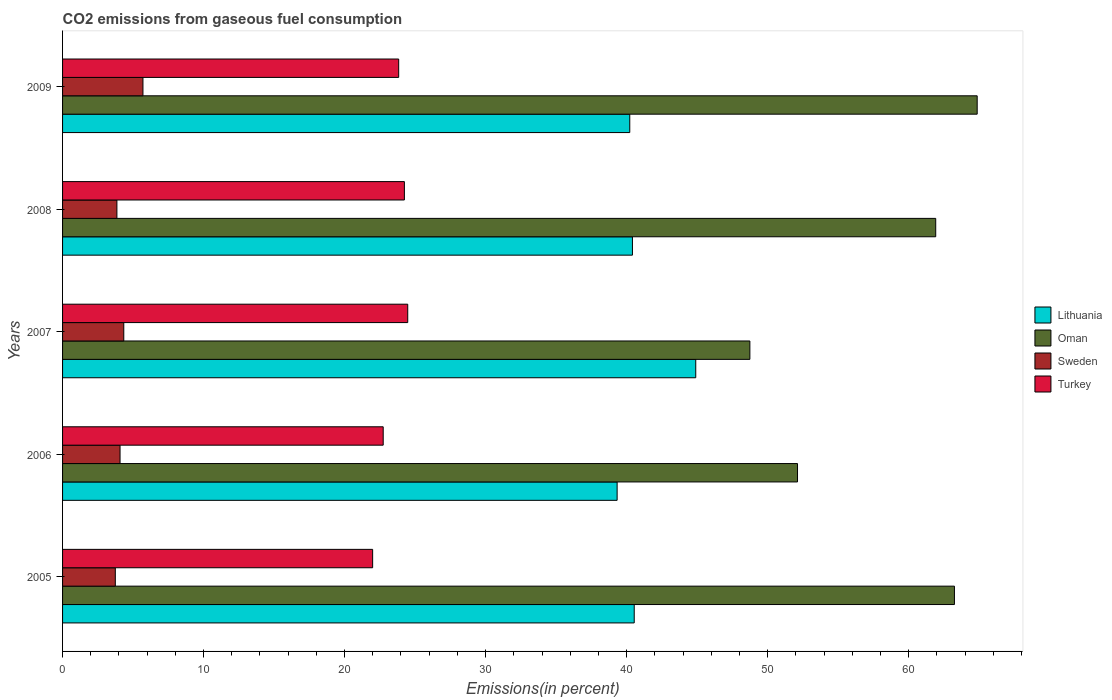How many different coloured bars are there?
Your response must be concise. 4. Are the number of bars per tick equal to the number of legend labels?
Your answer should be compact. Yes. How many bars are there on the 2nd tick from the top?
Give a very brief answer. 4. How many bars are there on the 1st tick from the bottom?
Your answer should be compact. 4. What is the label of the 5th group of bars from the top?
Provide a short and direct response. 2005. What is the total CO2 emitted in Sweden in 2009?
Your answer should be compact. 5.7. Across all years, what is the maximum total CO2 emitted in Turkey?
Your answer should be compact. 24.48. Across all years, what is the minimum total CO2 emitted in Lithuania?
Give a very brief answer. 39.33. In which year was the total CO2 emitted in Oman maximum?
Provide a succinct answer. 2009. What is the total total CO2 emitted in Turkey in the graph?
Your answer should be compact. 117.28. What is the difference between the total CO2 emitted in Oman in 2005 and that in 2008?
Offer a terse response. 1.33. What is the difference between the total CO2 emitted in Lithuania in 2006 and the total CO2 emitted in Turkey in 2008?
Your answer should be very brief. 15.09. What is the average total CO2 emitted in Lithuania per year?
Your answer should be compact. 41.08. In the year 2006, what is the difference between the total CO2 emitted in Lithuania and total CO2 emitted in Oman?
Give a very brief answer. -12.79. In how many years, is the total CO2 emitted in Oman greater than 64 %?
Your answer should be compact. 1. What is the ratio of the total CO2 emitted in Oman in 2008 to that in 2009?
Keep it short and to the point. 0.95. What is the difference between the highest and the second highest total CO2 emitted in Lithuania?
Offer a very short reply. 4.36. What is the difference between the highest and the lowest total CO2 emitted in Sweden?
Ensure brevity in your answer.  1.96. In how many years, is the total CO2 emitted in Turkey greater than the average total CO2 emitted in Turkey taken over all years?
Offer a terse response. 3. Is the sum of the total CO2 emitted in Oman in 2007 and 2009 greater than the maximum total CO2 emitted in Turkey across all years?
Offer a terse response. Yes. What does the 1st bar from the bottom in 2005 represents?
Your answer should be very brief. Lithuania. Are all the bars in the graph horizontal?
Your answer should be compact. Yes. How are the legend labels stacked?
Provide a succinct answer. Vertical. What is the title of the graph?
Ensure brevity in your answer.  CO2 emissions from gaseous fuel consumption. Does "Congo (Republic)" appear as one of the legend labels in the graph?
Your answer should be compact. No. What is the label or title of the X-axis?
Provide a succinct answer. Emissions(in percent). What is the Emissions(in percent) in Lithuania in 2005?
Your answer should be very brief. 40.54. What is the Emissions(in percent) in Oman in 2005?
Ensure brevity in your answer.  63.25. What is the Emissions(in percent) of Sweden in 2005?
Give a very brief answer. 3.74. What is the Emissions(in percent) in Turkey in 2005?
Your answer should be very brief. 21.99. What is the Emissions(in percent) of Lithuania in 2006?
Ensure brevity in your answer.  39.33. What is the Emissions(in percent) of Oman in 2006?
Ensure brevity in your answer.  52.12. What is the Emissions(in percent) of Sweden in 2006?
Your answer should be compact. 4.08. What is the Emissions(in percent) in Turkey in 2006?
Keep it short and to the point. 22.74. What is the Emissions(in percent) of Lithuania in 2007?
Provide a succinct answer. 44.9. What is the Emissions(in percent) of Oman in 2007?
Give a very brief answer. 48.74. What is the Emissions(in percent) of Sweden in 2007?
Your response must be concise. 4.34. What is the Emissions(in percent) in Turkey in 2007?
Your answer should be compact. 24.48. What is the Emissions(in percent) in Lithuania in 2008?
Offer a terse response. 40.41. What is the Emissions(in percent) of Oman in 2008?
Your answer should be very brief. 61.92. What is the Emissions(in percent) in Sweden in 2008?
Provide a succinct answer. 3.85. What is the Emissions(in percent) in Turkey in 2008?
Your response must be concise. 24.24. What is the Emissions(in percent) in Lithuania in 2009?
Make the answer very short. 40.22. What is the Emissions(in percent) of Oman in 2009?
Give a very brief answer. 64.86. What is the Emissions(in percent) of Sweden in 2009?
Offer a terse response. 5.7. What is the Emissions(in percent) of Turkey in 2009?
Your answer should be compact. 23.84. Across all years, what is the maximum Emissions(in percent) in Lithuania?
Offer a very short reply. 44.9. Across all years, what is the maximum Emissions(in percent) in Oman?
Give a very brief answer. 64.86. Across all years, what is the maximum Emissions(in percent) in Sweden?
Offer a very short reply. 5.7. Across all years, what is the maximum Emissions(in percent) of Turkey?
Your response must be concise. 24.48. Across all years, what is the minimum Emissions(in percent) of Lithuania?
Your answer should be very brief. 39.33. Across all years, what is the minimum Emissions(in percent) of Oman?
Your response must be concise. 48.74. Across all years, what is the minimum Emissions(in percent) of Sweden?
Ensure brevity in your answer.  3.74. Across all years, what is the minimum Emissions(in percent) of Turkey?
Your answer should be compact. 21.99. What is the total Emissions(in percent) in Lithuania in the graph?
Give a very brief answer. 205.41. What is the total Emissions(in percent) of Oman in the graph?
Give a very brief answer. 290.89. What is the total Emissions(in percent) in Sweden in the graph?
Offer a terse response. 21.71. What is the total Emissions(in percent) in Turkey in the graph?
Offer a very short reply. 117.28. What is the difference between the Emissions(in percent) in Lithuania in 2005 and that in 2006?
Provide a short and direct response. 1.21. What is the difference between the Emissions(in percent) in Oman in 2005 and that in 2006?
Your response must be concise. 11.13. What is the difference between the Emissions(in percent) of Sweden in 2005 and that in 2006?
Make the answer very short. -0.34. What is the difference between the Emissions(in percent) of Turkey in 2005 and that in 2006?
Provide a short and direct response. -0.75. What is the difference between the Emissions(in percent) of Lithuania in 2005 and that in 2007?
Provide a succinct answer. -4.36. What is the difference between the Emissions(in percent) of Oman in 2005 and that in 2007?
Offer a very short reply. 14.51. What is the difference between the Emissions(in percent) of Sweden in 2005 and that in 2007?
Offer a very short reply. -0.6. What is the difference between the Emissions(in percent) of Turkey in 2005 and that in 2007?
Offer a terse response. -2.49. What is the difference between the Emissions(in percent) of Lithuania in 2005 and that in 2008?
Your answer should be very brief. 0.13. What is the difference between the Emissions(in percent) in Oman in 2005 and that in 2008?
Give a very brief answer. 1.33. What is the difference between the Emissions(in percent) in Sweden in 2005 and that in 2008?
Keep it short and to the point. -0.11. What is the difference between the Emissions(in percent) of Turkey in 2005 and that in 2008?
Your response must be concise. -2.25. What is the difference between the Emissions(in percent) of Lithuania in 2005 and that in 2009?
Provide a succinct answer. 0.32. What is the difference between the Emissions(in percent) of Oman in 2005 and that in 2009?
Your response must be concise. -1.61. What is the difference between the Emissions(in percent) in Sweden in 2005 and that in 2009?
Ensure brevity in your answer.  -1.96. What is the difference between the Emissions(in percent) in Turkey in 2005 and that in 2009?
Provide a succinct answer. -1.85. What is the difference between the Emissions(in percent) of Lithuania in 2006 and that in 2007?
Your response must be concise. -5.58. What is the difference between the Emissions(in percent) in Oman in 2006 and that in 2007?
Provide a short and direct response. 3.38. What is the difference between the Emissions(in percent) in Sweden in 2006 and that in 2007?
Your answer should be very brief. -0.27. What is the difference between the Emissions(in percent) of Turkey in 2006 and that in 2007?
Keep it short and to the point. -1.74. What is the difference between the Emissions(in percent) of Lithuania in 2006 and that in 2008?
Provide a short and direct response. -1.09. What is the difference between the Emissions(in percent) in Oman in 2006 and that in 2008?
Keep it short and to the point. -9.8. What is the difference between the Emissions(in percent) in Sweden in 2006 and that in 2008?
Your answer should be very brief. 0.22. What is the difference between the Emissions(in percent) in Turkey in 2006 and that in 2008?
Give a very brief answer. -1.5. What is the difference between the Emissions(in percent) in Lithuania in 2006 and that in 2009?
Your answer should be very brief. -0.9. What is the difference between the Emissions(in percent) of Oman in 2006 and that in 2009?
Give a very brief answer. -12.74. What is the difference between the Emissions(in percent) in Sweden in 2006 and that in 2009?
Your answer should be compact. -1.62. What is the difference between the Emissions(in percent) of Turkey in 2006 and that in 2009?
Your response must be concise. -1.1. What is the difference between the Emissions(in percent) in Lithuania in 2007 and that in 2008?
Give a very brief answer. 4.49. What is the difference between the Emissions(in percent) in Oman in 2007 and that in 2008?
Your answer should be compact. -13.18. What is the difference between the Emissions(in percent) of Sweden in 2007 and that in 2008?
Offer a terse response. 0.49. What is the difference between the Emissions(in percent) of Turkey in 2007 and that in 2008?
Provide a short and direct response. 0.24. What is the difference between the Emissions(in percent) in Lithuania in 2007 and that in 2009?
Offer a very short reply. 4.68. What is the difference between the Emissions(in percent) of Oman in 2007 and that in 2009?
Keep it short and to the point. -16.12. What is the difference between the Emissions(in percent) in Sweden in 2007 and that in 2009?
Offer a terse response. -1.36. What is the difference between the Emissions(in percent) of Turkey in 2007 and that in 2009?
Offer a terse response. 0.64. What is the difference between the Emissions(in percent) in Lithuania in 2008 and that in 2009?
Keep it short and to the point. 0.19. What is the difference between the Emissions(in percent) in Oman in 2008 and that in 2009?
Provide a short and direct response. -2.94. What is the difference between the Emissions(in percent) in Sweden in 2008 and that in 2009?
Offer a very short reply. -1.85. What is the difference between the Emissions(in percent) in Turkey in 2008 and that in 2009?
Provide a succinct answer. 0.4. What is the difference between the Emissions(in percent) in Lithuania in 2005 and the Emissions(in percent) in Oman in 2006?
Keep it short and to the point. -11.58. What is the difference between the Emissions(in percent) of Lithuania in 2005 and the Emissions(in percent) of Sweden in 2006?
Your response must be concise. 36.46. What is the difference between the Emissions(in percent) of Lithuania in 2005 and the Emissions(in percent) of Turkey in 2006?
Make the answer very short. 17.8. What is the difference between the Emissions(in percent) in Oman in 2005 and the Emissions(in percent) in Sweden in 2006?
Provide a succinct answer. 59.17. What is the difference between the Emissions(in percent) in Oman in 2005 and the Emissions(in percent) in Turkey in 2006?
Keep it short and to the point. 40.51. What is the difference between the Emissions(in percent) in Sweden in 2005 and the Emissions(in percent) in Turkey in 2006?
Your response must be concise. -19. What is the difference between the Emissions(in percent) of Lithuania in 2005 and the Emissions(in percent) of Oman in 2007?
Offer a very short reply. -8.2. What is the difference between the Emissions(in percent) in Lithuania in 2005 and the Emissions(in percent) in Sweden in 2007?
Your answer should be compact. 36.2. What is the difference between the Emissions(in percent) of Lithuania in 2005 and the Emissions(in percent) of Turkey in 2007?
Ensure brevity in your answer.  16.06. What is the difference between the Emissions(in percent) of Oman in 2005 and the Emissions(in percent) of Sweden in 2007?
Give a very brief answer. 58.91. What is the difference between the Emissions(in percent) in Oman in 2005 and the Emissions(in percent) in Turkey in 2007?
Give a very brief answer. 38.77. What is the difference between the Emissions(in percent) of Sweden in 2005 and the Emissions(in percent) of Turkey in 2007?
Provide a succinct answer. -20.74. What is the difference between the Emissions(in percent) in Lithuania in 2005 and the Emissions(in percent) in Oman in 2008?
Give a very brief answer. -21.38. What is the difference between the Emissions(in percent) of Lithuania in 2005 and the Emissions(in percent) of Sweden in 2008?
Offer a terse response. 36.69. What is the difference between the Emissions(in percent) in Lithuania in 2005 and the Emissions(in percent) in Turkey in 2008?
Provide a short and direct response. 16.3. What is the difference between the Emissions(in percent) in Oman in 2005 and the Emissions(in percent) in Sweden in 2008?
Offer a very short reply. 59.39. What is the difference between the Emissions(in percent) of Oman in 2005 and the Emissions(in percent) of Turkey in 2008?
Make the answer very short. 39.01. What is the difference between the Emissions(in percent) in Sweden in 2005 and the Emissions(in percent) in Turkey in 2008?
Offer a terse response. -20.5. What is the difference between the Emissions(in percent) in Lithuania in 2005 and the Emissions(in percent) in Oman in 2009?
Ensure brevity in your answer.  -24.32. What is the difference between the Emissions(in percent) in Lithuania in 2005 and the Emissions(in percent) in Sweden in 2009?
Your answer should be very brief. 34.84. What is the difference between the Emissions(in percent) in Lithuania in 2005 and the Emissions(in percent) in Turkey in 2009?
Keep it short and to the point. 16.7. What is the difference between the Emissions(in percent) of Oman in 2005 and the Emissions(in percent) of Sweden in 2009?
Offer a very short reply. 57.55. What is the difference between the Emissions(in percent) of Oman in 2005 and the Emissions(in percent) of Turkey in 2009?
Provide a succinct answer. 39.41. What is the difference between the Emissions(in percent) in Sweden in 2005 and the Emissions(in percent) in Turkey in 2009?
Keep it short and to the point. -20.1. What is the difference between the Emissions(in percent) in Lithuania in 2006 and the Emissions(in percent) in Oman in 2007?
Your response must be concise. -9.41. What is the difference between the Emissions(in percent) in Lithuania in 2006 and the Emissions(in percent) in Sweden in 2007?
Your response must be concise. 34.99. What is the difference between the Emissions(in percent) of Lithuania in 2006 and the Emissions(in percent) of Turkey in 2007?
Your answer should be compact. 14.85. What is the difference between the Emissions(in percent) of Oman in 2006 and the Emissions(in percent) of Sweden in 2007?
Offer a terse response. 47.78. What is the difference between the Emissions(in percent) in Oman in 2006 and the Emissions(in percent) in Turkey in 2007?
Your answer should be compact. 27.64. What is the difference between the Emissions(in percent) in Sweden in 2006 and the Emissions(in percent) in Turkey in 2007?
Your answer should be very brief. -20.4. What is the difference between the Emissions(in percent) in Lithuania in 2006 and the Emissions(in percent) in Oman in 2008?
Your response must be concise. -22.59. What is the difference between the Emissions(in percent) in Lithuania in 2006 and the Emissions(in percent) in Sweden in 2008?
Offer a very short reply. 35.47. What is the difference between the Emissions(in percent) of Lithuania in 2006 and the Emissions(in percent) of Turkey in 2008?
Your answer should be very brief. 15.09. What is the difference between the Emissions(in percent) of Oman in 2006 and the Emissions(in percent) of Sweden in 2008?
Give a very brief answer. 48.27. What is the difference between the Emissions(in percent) in Oman in 2006 and the Emissions(in percent) in Turkey in 2008?
Make the answer very short. 27.88. What is the difference between the Emissions(in percent) of Sweden in 2006 and the Emissions(in percent) of Turkey in 2008?
Your response must be concise. -20.16. What is the difference between the Emissions(in percent) of Lithuania in 2006 and the Emissions(in percent) of Oman in 2009?
Ensure brevity in your answer.  -25.53. What is the difference between the Emissions(in percent) of Lithuania in 2006 and the Emissions(in percent) of Sweden in 2009?
Provide a succinct answer. 33.63. What is the difference between the Emissions(in percent) in Lithuania in 2006 and the Emissions(in percent) in Turkey in 2009?
Offer a very short reply. 15.49. What is the difference between the Emissions(in percent) of Oman in 2006 and the Emissions(in percent) of Sweden in 2009?
Keep it short and to the point. 46.42. What is the difference between the Emissions(in percent) of Oman in 2006 and the Emissions(in percent) of Turkey in 2009?
Ensure brevity in your answer.  28.28. What is the difference between the Emissions(in percent) in Sweden in 2006 and the Emissions(in percent) in Turkey in 2009?
Your answer should be very brief. -19.76. What is the difference between the Emissions(in percent) in Lithuania in 2007 and the Emissions(in percent) in Oman in 2008?
Keep it short and to the point. -17.02. What is the difference between the Emissions(in percent) in Lithuania in 2007 and the Emissions(in percent) in Sweden in 2008?
Your answer should be very brief. 41.05. What is the difference between the Emissions(in percent) of Lithuania in 2007 and the Emissions(in percent) of Turkey in 2008?
Provide a succinct answer. 20.66. What is the difference between the Emissions(in percent) of Oman in 2007 and the Emissions(in percent) of Sweden in 2008?
Ensure brevity in your answer.  44.89. What is the difference between the Emissions(in percent) in Oman in 2007 and the Emissions(in percent) in Turkey in 2008?
Offer a terse response. 24.5. What is the difference between the Emissions(in percent) of Sweden in 2007 and the Emissions(in percent) of Turkey in 2008?
Your response must be concise. -19.9. What is the difference between the Emissions(in percent) in Lithuania in 2007 and the Emissions(in percent) in Oman in 2009?
Your response must be concise. -19.96. What is the difference between the Emissions(in percent) in Lithuania in 2007 and the Emissions(in percent) in Sweden in 2009?
Make the answer very short. 39.2. What is the difference between the Emissions(in percent) of Lithuania in 2007 and the Emissions(in percent) of Turkey in 2009?
Make the answer very short. 21.07. What is the difference between the Emissions(in percent) in Oman in 2007 and the Emissions(in percent) in Sweden in 2009?
Offer a terse response. 43.04. What is the difference between the Emissions(in percent) in Oman in 2007 and the Emissions(in percent) in Turkey in 2009?
Provide a succinct answer. 24.9. What is the difference between the Emissions(in percent) of Sweden in 2007 and the Emissions(in percent) of Turkey in 2009?
Provide a succinct answer. -19.5. What is the difference between the Emissions(in percent) in Lithuania in 2008 and the Emissions(in percent) in Oman in 2009?
Keep it short and to the point. -24.45. What is the difference between the Emissions(in percent) in Lithuania in 2008 and the Emissions(in percent) in Sweden in 2009?
Give a very brief answer. 34.71. What is the difference between the Emissions(in percent) in Lithuania in 2008 and the Emissions(in percent) in Turkey in 2009?
Offer a terse response. 16.58. What is the difference between the Emissions(in percent) in Oman in 2008 and the Emissions(in percent) in Sweden in 2009?
Keep it short and to the point. 56.22. What is the difference between the Emissions(in percent) in Oman in 2008 and the Emissions(in percent) in Turkey in 2009?
Provide a short and direct response. 38.08. What is the difference between the Emissions(in percent) in Sweden in 2008 and the Emissions(in percent) in Turkey in 2009?
Offer a very short reply. -19.98. What is the average Emissions(in percent) in Lithuania per year?
Provide a succinct answer. 41.08. What is the average Emissions(in percent) in Oman per year?
Provide a short and direct response. 58.18. What is the average Emissions(in percent) in Sweden per year?
Make the answer very short. 4.34. What is the average Emissions(in percent) of Turkey per year?
Keep it short and to the point. 23.46. In the year 2005, what is the difference between the Emissions(in percent) of Lithuania and Emissions(in percent) of Oman?
Your answer should be very brief. -22.71. In the year 2005, what is the difference between the Emissions(in percent) of Lithuania and Emissions(in percent) of Sweden?
Your response must be concise. 36.8. In the year 2005, what is the difference between the Emissions(in percent) in Lithuania and Emissions(in percent) in Turkey?
Provide a short and direct response. 18.55. In the year 2005, what is the difference between the Emissions(in percent) of Oman and Emissions(in percent) of Sweden?
Your response must be concise. 59.51. In the year 2005, what is the difference between the Emissions(in percent) of Oman and Emissions(in percent) of Turkey?
Offer a very short reply. 41.26. In the year 2005, what is the difference between the Emissions(in percent) in Sweden and Emissions(in percent) in Turkey?
Ensure brevity in your answer.  -18.25. In the year 2006, what is the difference between the Emissions(in percent) of Lithuania and Emissions(in percent) of Oman?
Offer a very short reply. -12.79. In the year 2006, what is the difference between the Emissions(in percent) in Lithuania and Emissions(in percent) in Sweden?
Your response must be concise. 35.25. In the year 2006, what is the difference between the Emissions(in percent) of Lithuania and Emissions(in percent) of Turkey?
Your response must be concise. 16.59. In the year 2006, what is the difference between the Emissions(in percent) in Oman and Emissions(in percent) in Sweden?
Provide a short and direct response. 48.04. In the year 2006, what is the difference between the Emissions(in percent) in Oman and Emissions(in percent) in Turkey?
Your answer should be compact. 29.38. In the year 2006, what is the difference between the Emissions(in percent) of Sweden and Emissions(in percent) of Turkey?
Your answer should be very brief. -18.66. In the year 2007, what is the difference between the Emissions(in percent) of Lithuania and Emissions(in percent) of Oman?
Offer a terse response. -3.84. In the year 2007, what is the difference between the Emissions(in percent) of Lithuania and Emissions(in percent) of Sweden?
Your response must be concise. 40.56. In the year 2007, what is the difference between the Emissions(in percent) of Lithuania and Emissions(in percent) of Turkey?
Make the answer very short. 20.42. In the year 2007, what is the difference between the Emissions(in percent) of Oman and Emissions(in percent) of Sweden?
Keep it short and to the point. 44.4. In the year 2007, what is the difference between the Emissions(in percent) of Oman and Emissions(in percent) of Turkey?
Ensure brevity in your answer.  24.26. In the year 2007, what is the difference between the Emissions(in percent) in Sweden and Emissions(in percent) in Turkey?
Ensure brevity in your answer.  -20.14. In the year 2008, what is the difference between the Emissions(in percent) of Lithuania and Emissions(in percent) of Oman?
Your response must be concise. -21.51. In the year 2008, what is the difference between the Emissions(in percent) in Lithuania and Emissions(in percent) in Sweden?
Your response must be concise. 36.56. In the year 2008, what is the difference between the Emissions(in percent) of Lithuania and Emissions(in percent) of Turkey?
Give a very brief answer. 16.17. In the year 2008, what is the difference between the Emissions(in percent) in Oman and Emissions(in percent) in Sweden?
Provide a succinct answer. 58.07. In the year 2008, what is the difference between the Emissions(in percent) of Oman and Emissions(in percent) of Turkey?
Offer a very short reply. 37.68. In the year 2008, what is the difference between the Emissions(in percent) of Sweden and Emissions(in percent) of Turkey?
Ensure brevity in your answer.  -20.39. In the year 2009, what is the difference between the Emissions(in percent) of Lithuania and Emissions(in percent) of Oman?
Your answer should be compact. -24.64. In the year 2009, what is the difference between the Emissions(in percent) in Lithuania and Emissions(in percent) in Sweden?
Provide a succinct answer. 34.52. In the year 2009, what is the difference between the Emissions(in percent) of Lithuania and Emissions(in percent) of Turkey?
Give a very brief answer. 16.39. In the year 2009, what is the difference between the Emissions(in percent) in Oman and Emissions(in percent) in Sweden?
Your answer should be very brief. 59.16. In the year 2009, what is the difference between the Emissions(in percent) of Oman and Emissions(in percent) of Turkey?
Your answer should be compact. 41.02. In the year 2009, what is the difference between the Emissions(in percent) of Sweden and Emissions(in percent) of Turkey?
Give a very brief answer. -18.14. What is the ratio of the Emissions(in percent) of Lithuania in 2005 to that in 2006?
Provide a short and direct response. 1.03. What is the ratio of the Emissions(in percent) of Oman in 2005 to that in 2006?
Keep it short and to the point. 1.21. What is the ratio of the Emissions(in percent) of Sweden in 2005 to that in 2006?
Ensure brevity in your answer.  0.92. What is the ratio of the Emissions(in percent) in Turkey in 2005 to that in 2006?
Provide a short and direct response. 0.97. What is the ratio of the Emissions(in percent) in Lithuania in 2005 to that in 2007?
Provide a short and direct response. 0.9. What is the ratio of the Emissions(in percent) in Oman in 2005 to that in 2007?
Provide a succinct answer. 1.3. What is the ratio of the Emissions(in percent) in Sweden in 2005 to that in 2007?
Keep it short and to the point. 0.86. What is the ratio of the Emissions(in percent) in Turkey in 2005 to that in 2007?
Offer a very short reply. 0.9. What is the ratio of the Emissions(in percent) of Oman in 2005 to that in 2008?
Your answer should be compact. 1.02. What is the ratio of the Emissions(in percent) in Sweden in 2005 to that in 2008?
Provide a succinct answer. 0.97. What is the ratio of the Emissions(in percent) in Turkey in 2005 to that in 2008?
Make the answer very short. 0.91. What is the ratio of the Emissions(in percent) in Oman in 2005 to that in 2009?
Ensure brevity in your answer.  0.98. What is the ratio of the Emissions(in percent) in Sweden in 2005 to that in 2009?
Keep it short and to the point. 0.66. What is the ratio of the Emissions(in percent) in Turkey in 2005 to that in 2009?
Offer a very short reply. 0.92. What is the ratio of the Emissions(in percent) of Lithuania in 2006 to that in 2007?
Keep it short and to the point. 0.88. What is the ratio of the Emissions(in percent) of Oman in 2006 to that in 2007?
Give a very brief answer. 1.07. What is the ratio of the Emissions(in percent) in Sweden in 2006 to that in 2007?
Offer a very short reply. 0.94. What is the ratio of the Emissions(in percent) in Turkey in 2006 to that in 2007?
Offer a very short reply. 0.93. What is the ratio of the Emissions(in percent) of Lithuania in 2006 to that in 2008?
Provide a short and direct response. 0.97. What is the ratio of the Emissions(in percent) in Oman in 2006 to that in 2008?
Provide a succinct answer. 0.84. What is the ratio of the Emissions(in percent) of Sweden in 2006 to that in 2008?
Your response must be concise. 1.06. What is the ratio of the Emissions(in percent) in Turkey in 2006 to that in 2008?
Give a very brief answer. 0.94. What is the ratio of the Emissions(in percent) in Lithuania in 2006 to that in 2009?
Provide a succinct answer. 0.98. What is the ratio of the Emissions(in percent) of Oman in 2006 to that in 2009?
Your answer should be very brief. 0.8. What is the ratio of the Emissions(in percent) of Sweden in 2006 to that in 2009?
Your response must be concise. 0.71. What is the ratio of the Emissions(in percent) of Turkey in 2006 to that in 2009?
Keep it short and to the point. 0.95. What is the ratio of the Emissions(in percent) of Oman in 2007 to that in 2008?
Keep it short and to the point. 0.79. What is the ratio of the Emissions(in percent) in Sweden in 2007 to that in 2008?
Your answer should be very brief. 1.13. What is the ratio of the Emissions(in percent) of Turkey in 2007 to that in 2008?
Offer a very short reply. 1.01. What is the ratio of the Emissions(in percent) of Lithuania in 2007 to that in 2009?
Your answer should be compact. 1.12. What is the ratio of the Emissions(in percent) of Oman in 2007 to that in 2009?
Keep it short and to the point. 0.75. What is the ratio of the Emissions(in percent) of Sweden in 2007 to that in 2009?
Ensure brevity in your answer.  0.76. What is the ratio of the Emissions(in percent) of Turkey in 2007 to that in 2009?
Provide a succinct answer. 1.03. What is the ratio of the Emissions(in percent) in Oman in 2008 to that in 2009?
Provide a short and direct response. 0.95. What is the ratio of the Emissions(in percent) of Sweden in 2008 to that in 2009?
Your response must be concise. 0.68. What is the ratio of the Emissions(in percent) of Turkey in 2008 to that in 2009?
Your answer should be compact. 1.02. What is the difference between the highest and the second highest Emissions(in percent) of Lithuania?
Your answer should be very brief. 4.36. What is the difference between the highest and the second highest Emissions(in percent) in Oman?
Keep it short and to the point. 1.61. What is the difference between the highest and the second highest Emissions(in percent) in Sweden?
Offer a very short reply. 1.36. What is the difference between the highest and the second highest Emissions(in percent) of Turkey?
Provide a succinct answer. 0.24. What is the difference between the highest and the lowest Emissions(in percent) of Lithuania?
Give a very brief answer. 5.58. What is the difference between the highest and the lowest Emissions(in percent) in Oman?
Your answer should be compact. 16.12. What is the difference between the highest and the lowest Emissions(in percent) in Sweden?
Your answer should be very brief. 1.96. What is the difference between the highest and the lowest Emissions(in percent) of Turkey?
Keep it short and to the point. 2.49. 